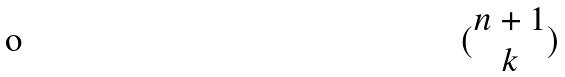<formula> <loc_0><loc_0><loc_500><loc_500>( \begin{matrix} n + 1 \\ k \end{matrix} )</formula> 